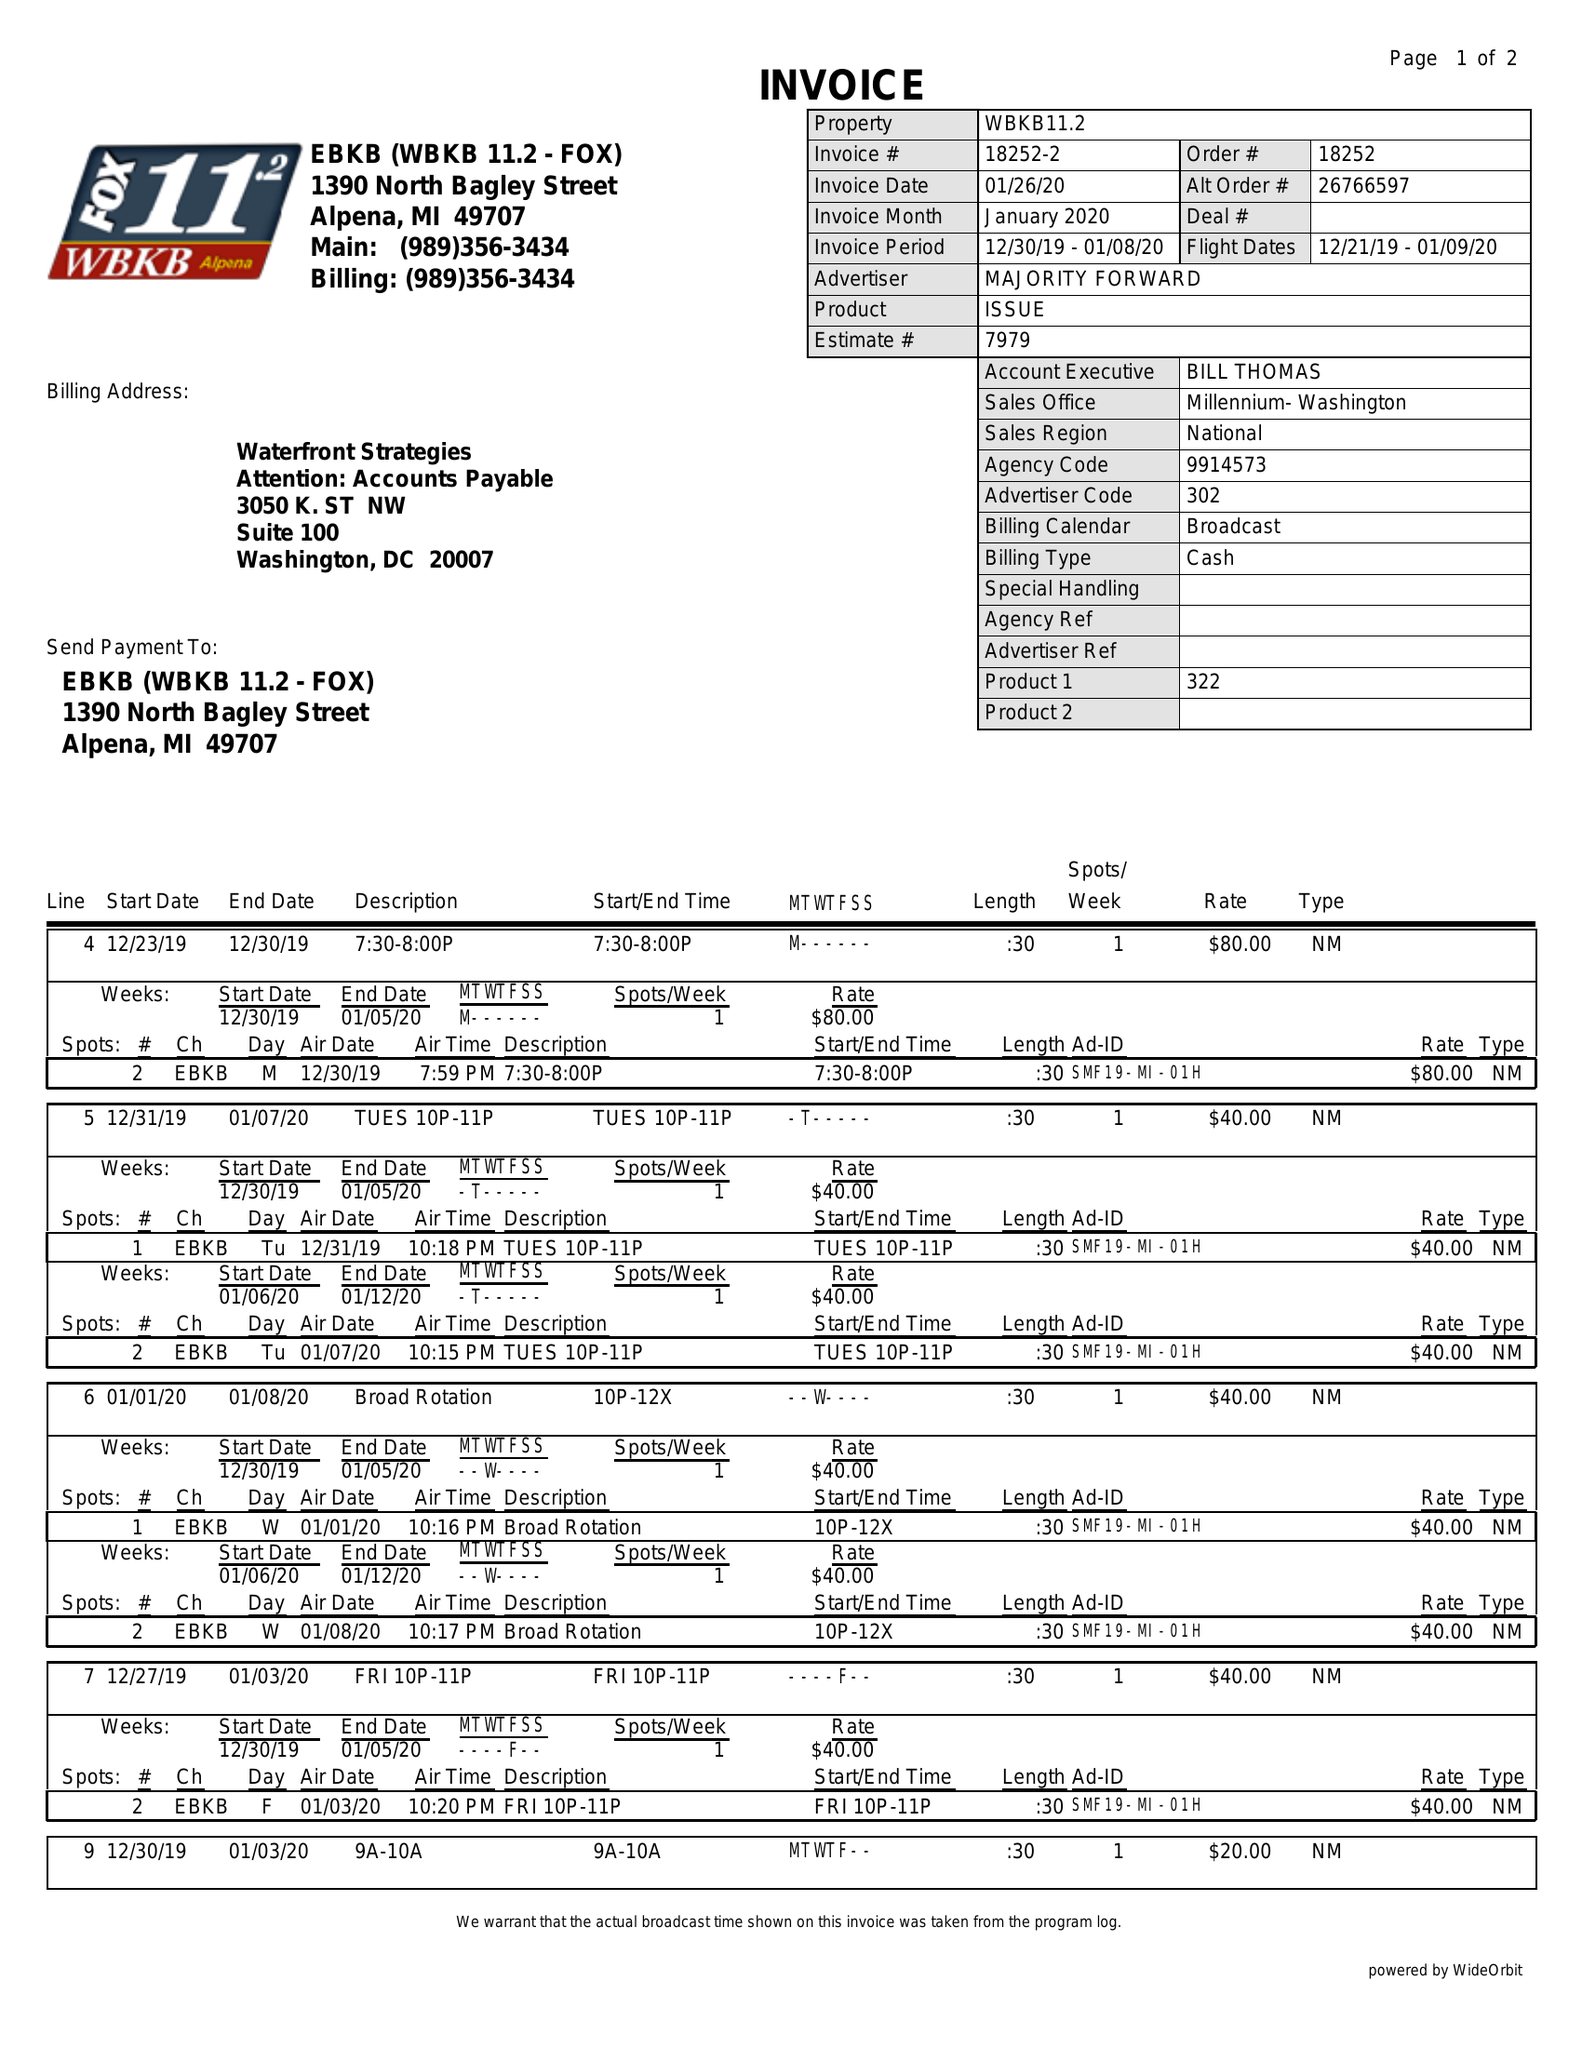What is the value for the contract_num?
Answer the question using a single word or phrase. 18252 